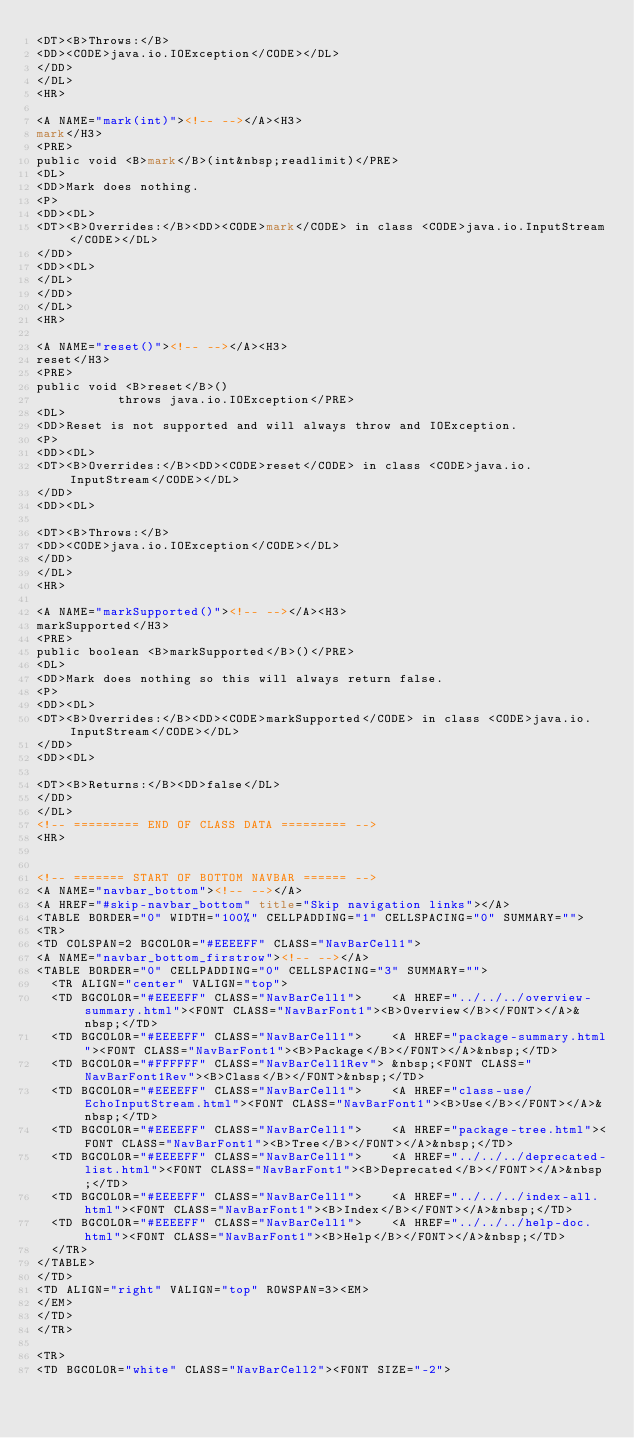Convert code to text. <code><loc_0><loc_0><loc_500><loc_500><_HTML_><DT><B>Throws:</B>
<DD><CODE>java.io.IOException</CODE></DL>
</DD>
</DL>
<HR>

<A NAME="mark(int)"><!-- --></A><H3>
mark</H3>
<PRE>
public void <B>mark</B>(int&nbsp;readlimit)</PRE>
<DL>
<DD>Mark does nothing.
<P>
<DD><DL>
<DT><B>Overrides:</B><DD><CODE>mark</CODE> in class <CODE>java.io.InputStream</CODE></DL>
</DD>
<DD><DL>
</DL>
</DD>
</DL>
<HR>

<A NAME="reset()"><!-- --></A><H3>
reset</H3>
<PRE>
public void <B>reset</B>()
           throws java.io.IOException</PRE>
<DL>
<DD>Reset is not supported and will always throw and IOException.
<P>
<DD><DL>
<DT><B>Overrides:</B><DD><CODE>reset</CODE> in class <CODE>java.io.InputStream</CODE></DL>
</DD>
<DD><DL>

<DT><B>Throws:</B>
<DD><CODE>java.io.IOException</CODE></DL>
</DD>
</DL>
<HR>

<A NAME="markSupported()"><!-- --></A><H3>
markSupported</H3>
<PRE>
public boolean <B>markSupported</B>()</PRE>
<DL>
<DD>Mark does nothing so this will always return false.
<P>
<DD><DL>
<DT><B>Overrides:</B><DD><CODE>markSupported</CODE> in class <CODE>java.io.InputStream</CODE></DL>
</DD>
<DD><DL>

<DT><B>Returns:</B><DD>false</DL>
</DD>
</DL>
<!-- ========= END OF CLASS DATA ========= -->
<HR>


<!-- ======= START OF BOTTOM NAVBAR ====== -->
<A NAME="navbar_bottom"><!-- --></A>
<A HREF="#skip-navbar_bottom" title="Skip navigation links"></A>
<TABLE BORDER="0" WIDTH="100%" CELLPADDING="1" CELLSPACING="0" SUMMARY="">
<TR>
<TD COLSPAN=2 BGCOLOR="#EEEEFF" CLASS="NavBarCell1">
<A NAME="navbar_bottom_firstrow"><!-- --></A>
<TABLE BORDER="0" CELLPADDING="0" CELLSPACING="3" SUMMARY="">
  <TR ALIGN="center" VALIGN="top">
  <TD BGCOLOR="#EEEEFF" CLASS="NavBarCell1">    <A HREF="../../../overview-summary.html"><FONT CLASS="NavBarFont1"><B>Overview</B></FONT></A>&nbsp;</TD>
  <TD BGCOLOR="#EEEEFF" CLASS="NavBarCell1">    <A HREF="package-summary.html"><FONT CLASS="NavBarFont1"><B>Package</B></FONT></A>&nbsp;</TD>
  <TD BGCOLOR="#FFFFFF" CLASS="NavBarCell1Rev"> &nbsp;<FONT CLASS="NavBarFont1Rev"><B>Class</B></FONT>&nbsp;</TD>
  <TD BGCOLOR="#EEEEFF" CLASS="NavBarCell1">    <A HREF="class-use/EchoInputStream.html"><FONT CLASS="NavBarFont1"><B>Use</B></FONT></A>&nbsp;</TD>
  <TD BGCOLOR="#EEEEFF" CLASS="NavBarCell1">    <A HREF="package-tree.html"><FONT CLASS="NavBarFont1"><B>Tree</B></FONT></A>&nbsp;</TD>
  <TD BGCOLOR="#EEEEFF" CLASS="NavBarCell1">    <A HREF="../../../deprecated-list.html"><FONT CLASS="NavBarFont1"><B>Deprecated</B></FONT></A>&nbsp;</TD>
  <TD BGCOLOR="#EEEEFF" CLASS="NavBarCell1">    <A HREF="../../../index-all.html"><FONT CLASS="NavBarFont1"><B>Index</B></FONT></A>&nbsp;</TD>
  <TD BGCOLOR="#EEEEFF" CLASS="NavBarCell1">    <A HREF="../../../help-doc.html"><FONT CLASS="NavBarFont1"><B>Help</B></FONT></A>&nbsp;</TD>
  </TR>
</TABLE>
</TD>
<TD ALIGN="right" VALIGN="top" ROWSPAN=3><EM>
</EM>
</TD>
</TR>

<TR>
<TD BGCOLOR="white" CLASS="NavBarCell2"><FONT SIZE="-2"></code> 